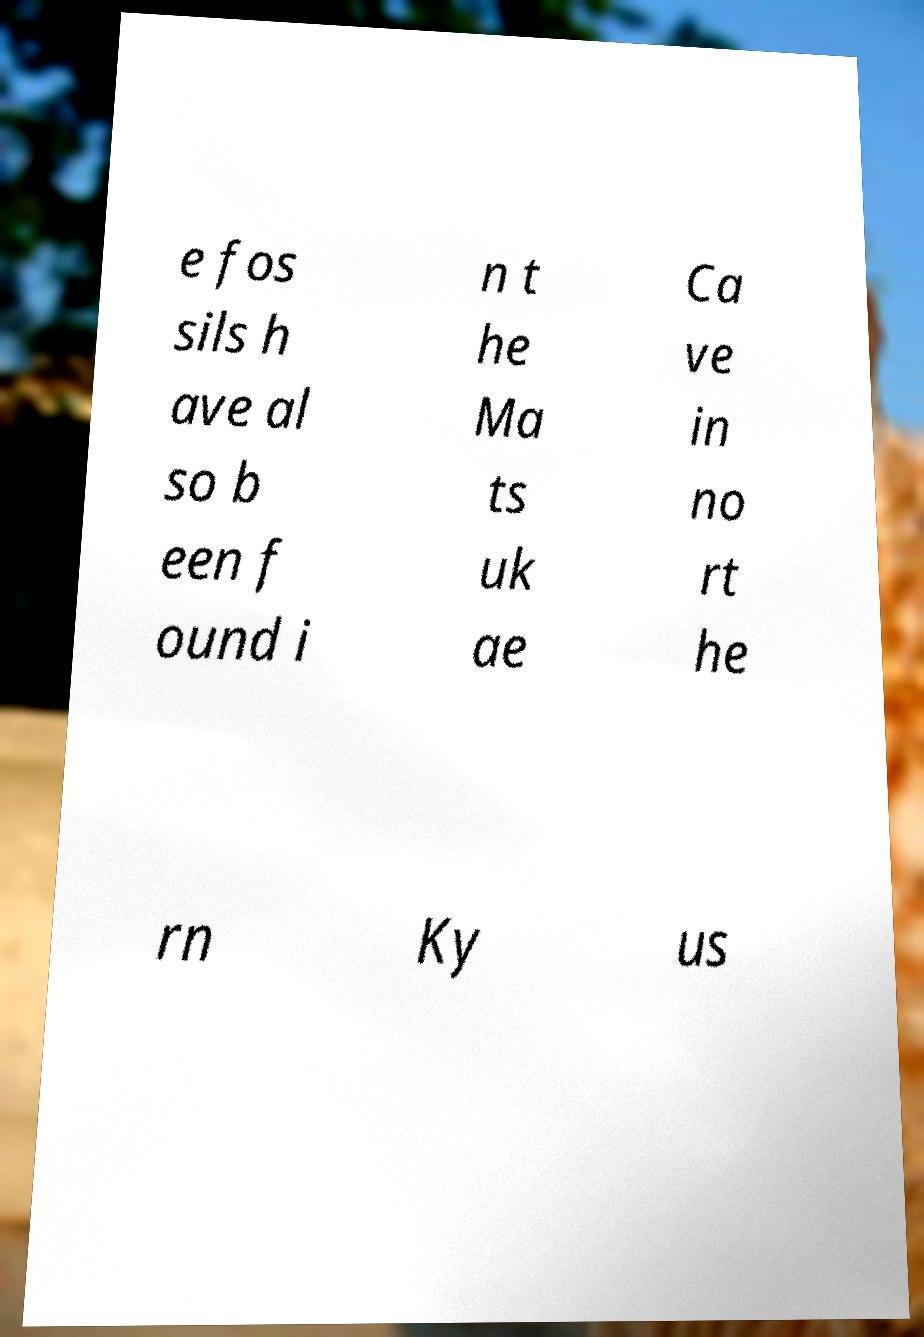Please identify and transcribe the text found in this image. e fos sils h ave al so b een f ound i n t he Ma ts uk ae Ca ve in no rt he rn Ky us 